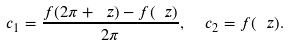Convert formula to latex. <formula><loc_0><loc_0><loc_500><loc_500>c _ { 1 } = \frac { f ( 2 \pi + \ z ) - f ( \ z ) } { 2 \pi } , \ \ c _ { 2 } = f ( \ z ) .</formula> 